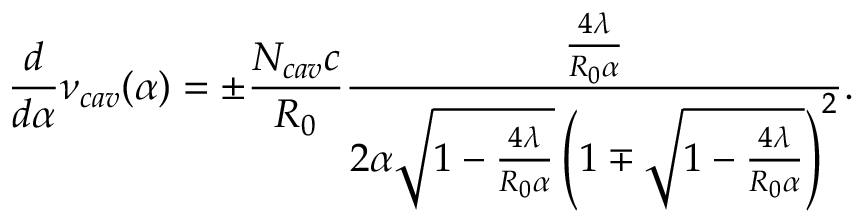Convert formula to latex. <formula><loc_0><loc_0><loc_500><loc_500>\frac { d } { d \alpha } \nu _ { c a v } ( \alpha ) = \pm \frac { N _ { c a v } c } { R _ { 0 } } \frac { \frac { 4 \lambda } { R _ { 0 } \alpha } } { 2 \alpha \sqrt { 1 - \frac { 4 \lambda } { R _ { 0 } \alpha } } \left ( 1 \mp \sqrt { 1 - \frac { 4 \lambda } { R _ { 0 } \alpha } } \right ) ^ { 2 } } .</formula> 